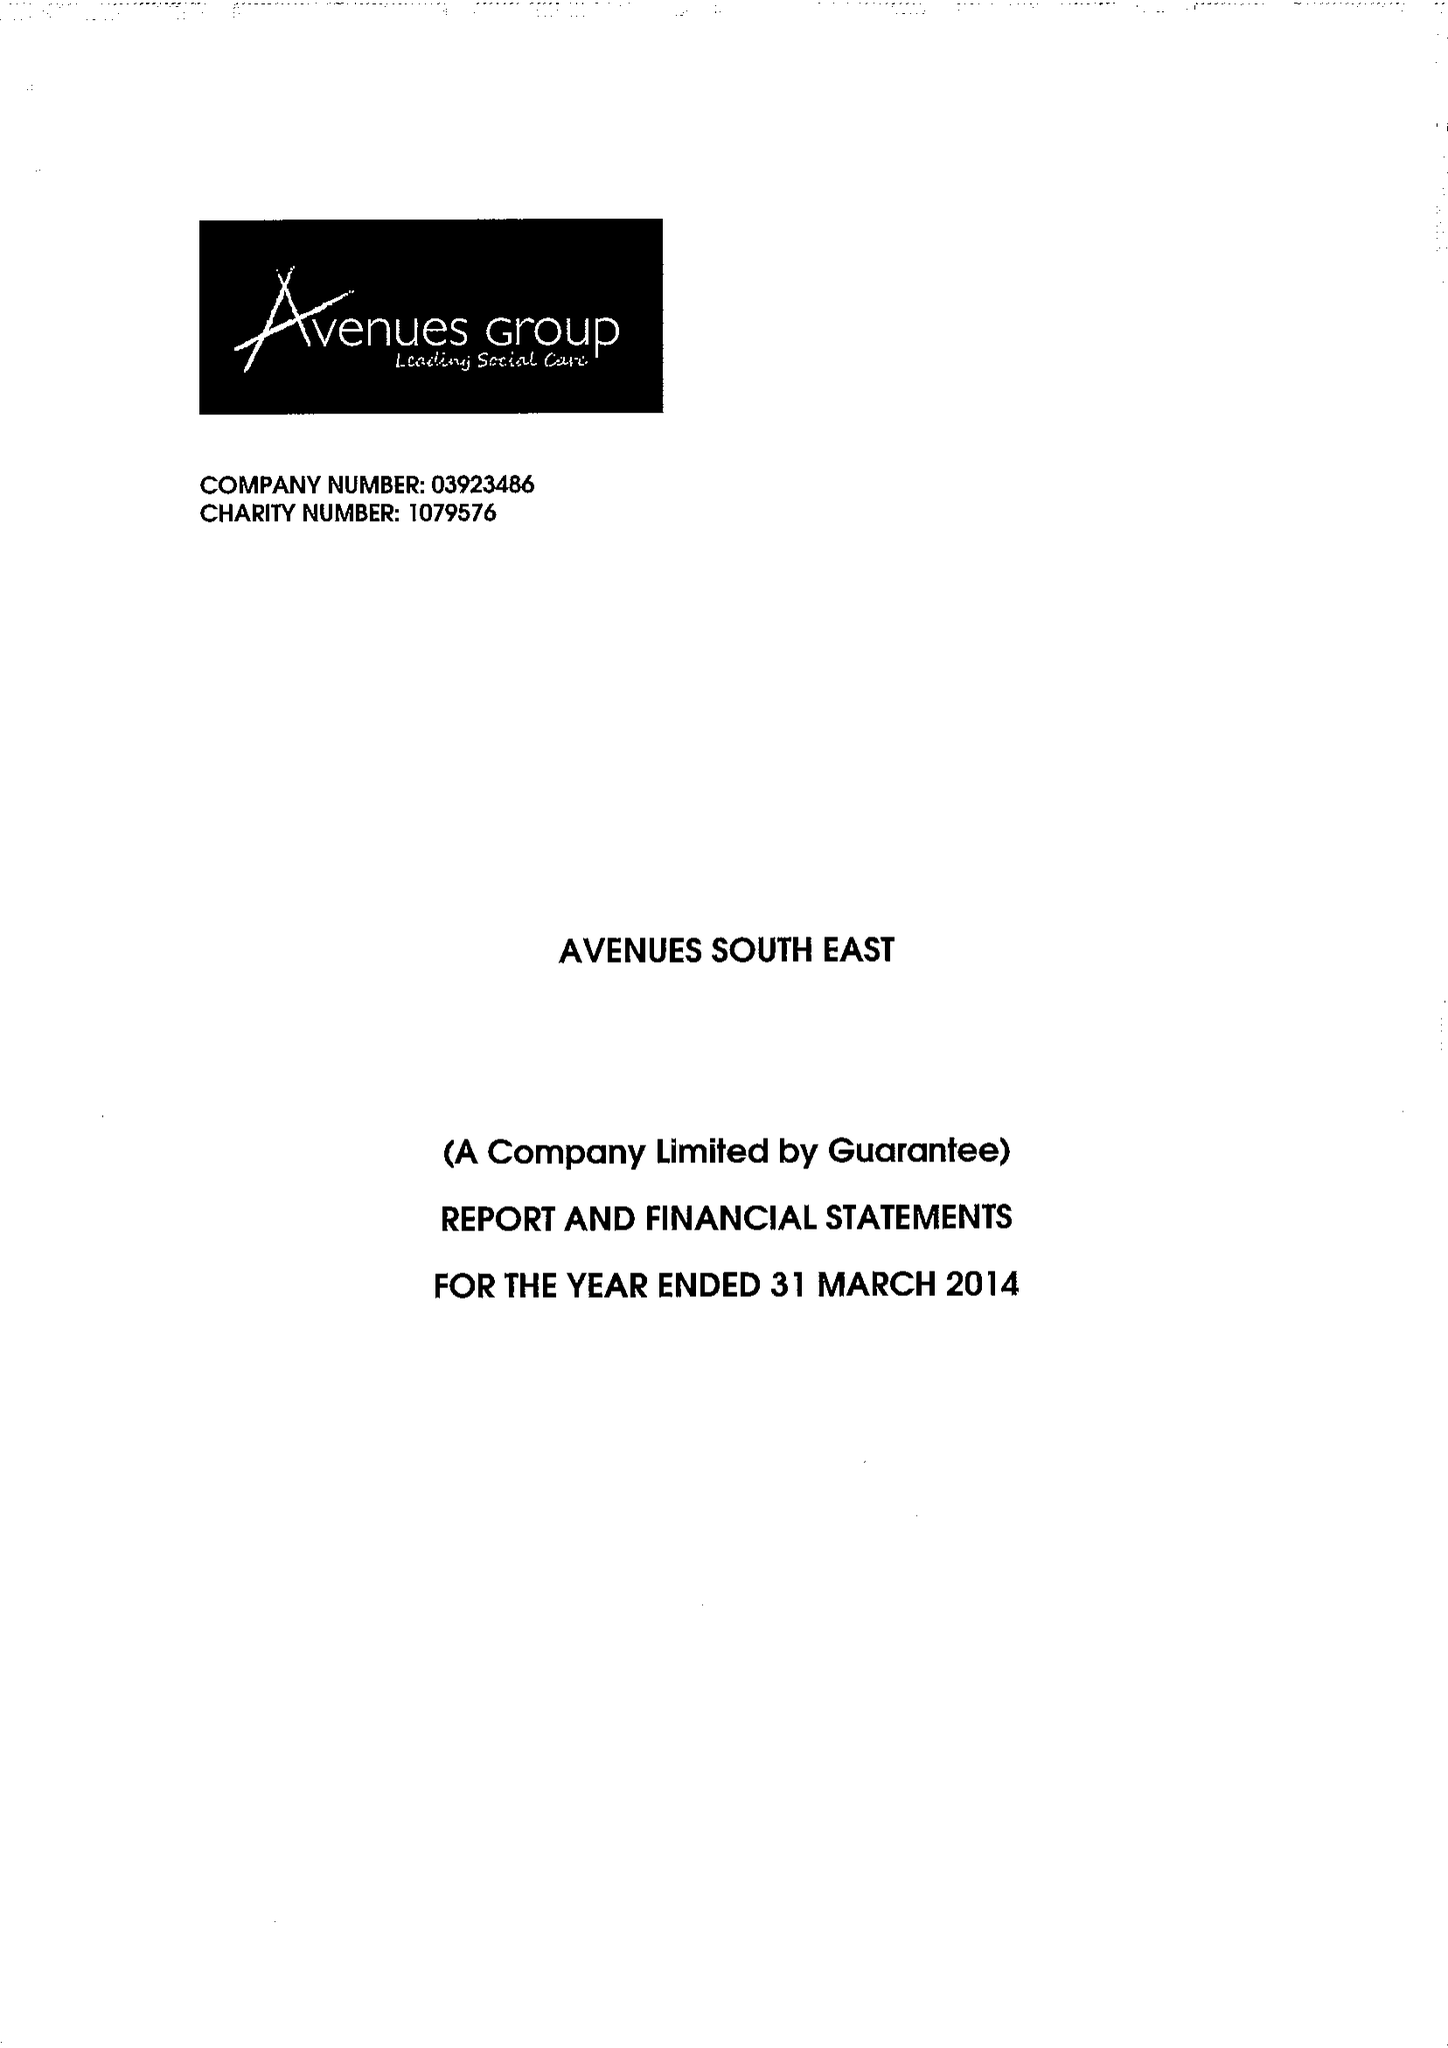What is the value for the address__postcode?
Answer the question using a single word or phrase. DA14 5TA 